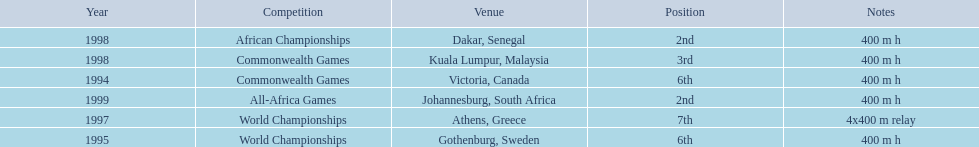What races did ken harden run? 400 m h, 400 m h, 4x400 m relay, 400 m h, 400 m h, 400 m h. Which race did ken harden run in 1997? 4x400 m relay. 